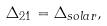Convert formula to latex. <formula><loc_0><loc_0><loc_500><loc_500>\Delta _ { 2 1 } = \Delta _ { s o l a r } ,</formula> 